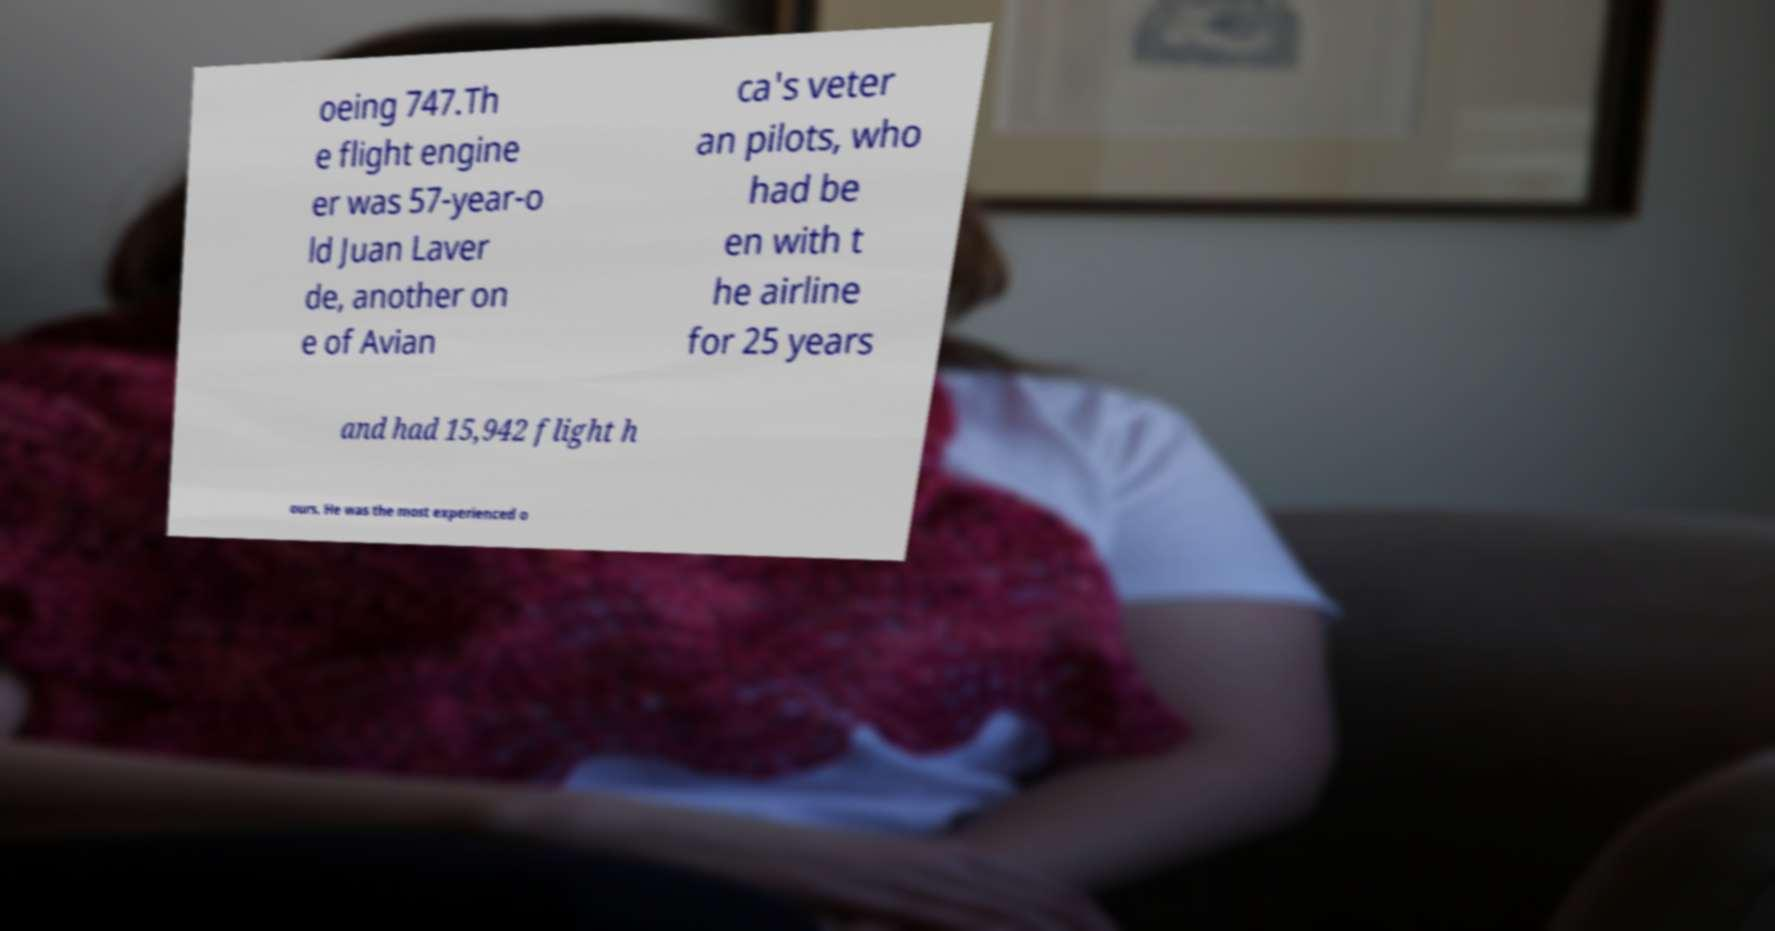There's text embedded in this image that I need extracted. Can you transcribe it verbatim? oeing 747.Th e flight engine er was 57-year-o ld Juan Laver de, another on e of Avian ca's veter an pilots, who had be en with t he airline for 25 years and had 15,942 flight h ours. He was the most experienced o 